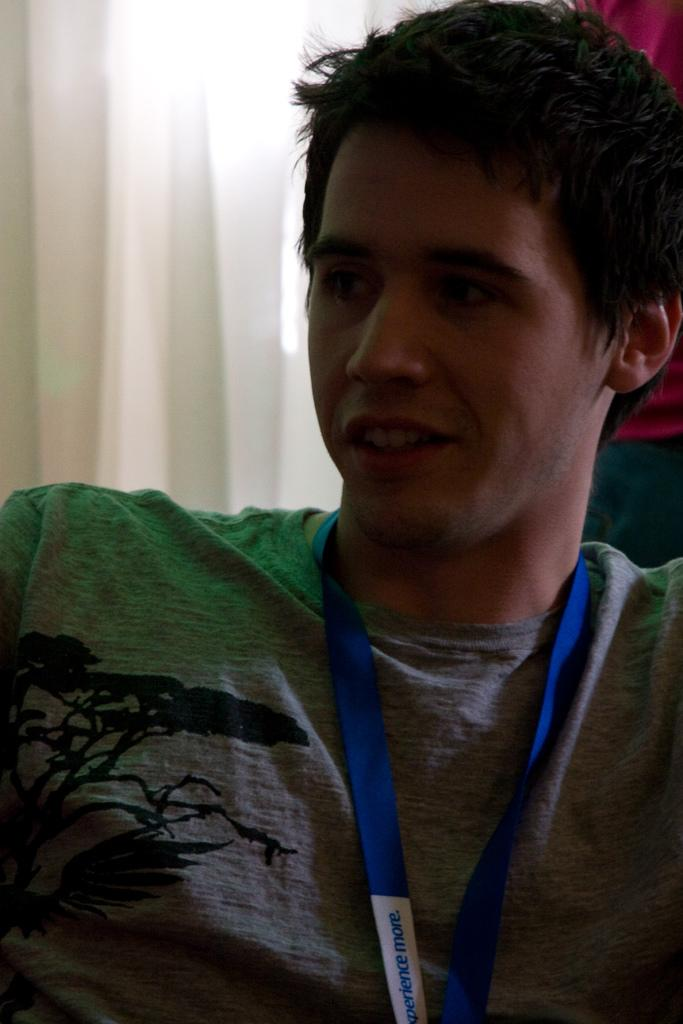Who is the main subject in the picture? There is a boy in the picture. What is the boy wearing? The boy is wearing a grey t-shirt. Can you describe any accessories the boy is wearing? The boy has a blue ID card around his neck. What is the boy's posture in the picture? The boy is sitting on a chair. In which direction is the boy looking? The boy is looking to the left side. What type of disgust can be seen on the boy's face in the image? There is no indication of disgust on the boy's face in the image. 